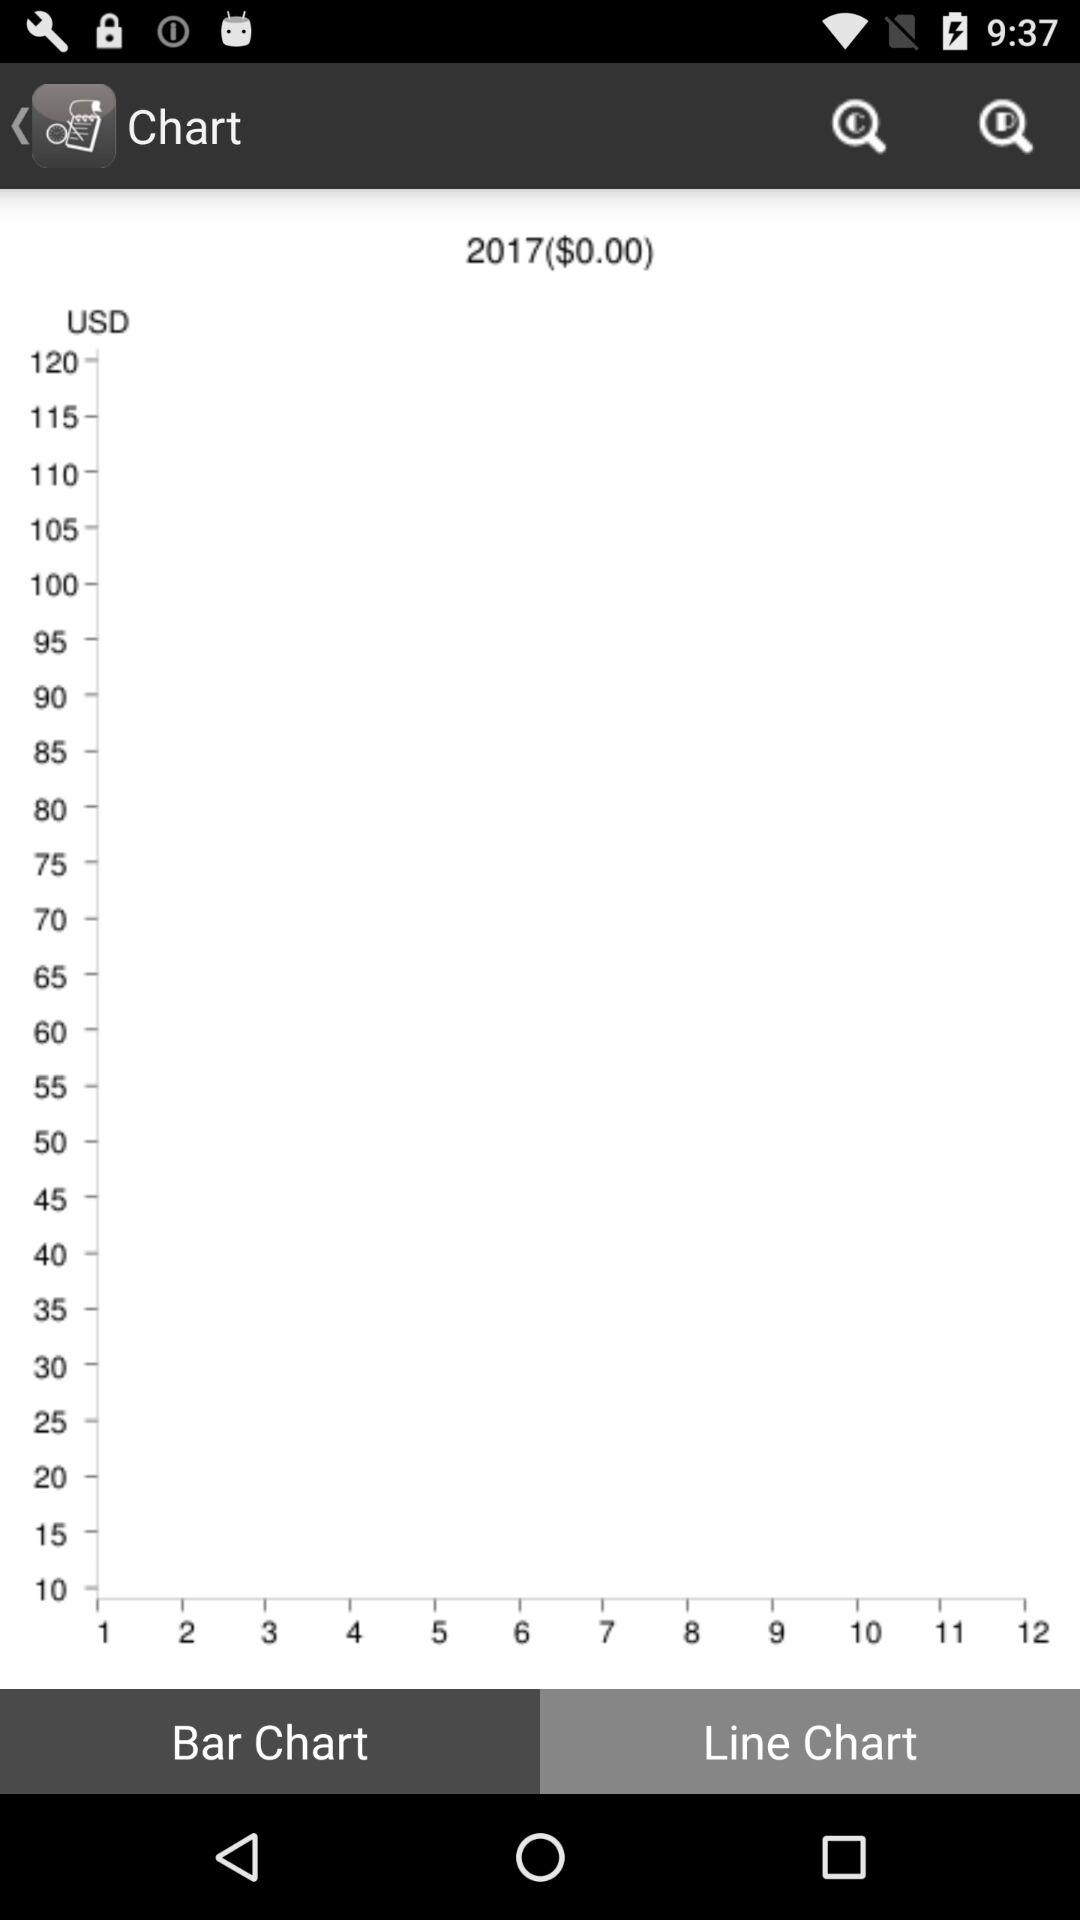What is being charted?
When the provided information is insufficient, respond with <no answer>. <no answer> 